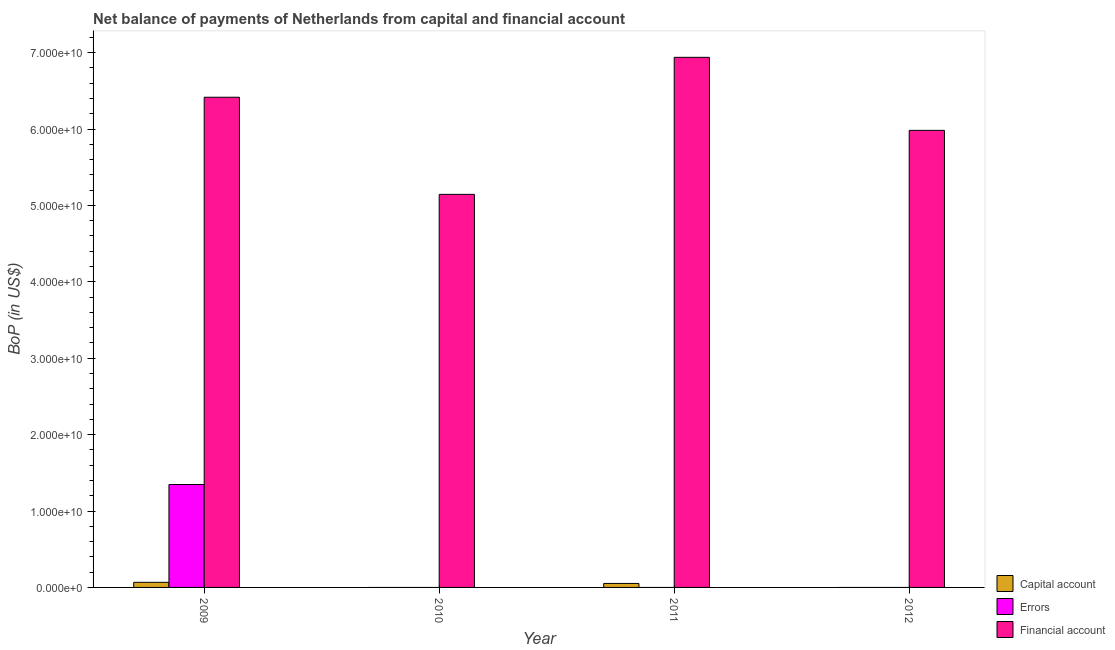How many different coloured bars are there?
Make the answer very short. 3. Are the number of bars on each tick of the X-axis equal?
Ensure brevity in your answer.  No. What is the label of the 4th group of bars from the left?
Keep it short and to the point. 2012. In how many cases, is the number of bars for a given year not equal to the number of legend labels?
Your response must be concise. 3. What is the amount of net capital account in 2011?
Keep it short and to the point. 5.21e+08. Across all years, what is the maximum amount of financial account?
Keep it short and to the point. 6.94e+1. What is the total amount of financial account in the graph?
Give a very brief answer. 2.45e+11. What is the difference between the amount of financial account in 2009 and that in 2012?
Offer a terse response. 4.34e+09. What is the difference between the amount of errors in 2011 and the amount of financial account in 2009?
Give a very brief answer. -1.35e+1. What is the average amount of net capital account per year?
Offer a very short reply. 2.97e+08. In the year 2011, what is the difference between the amount of net capital account and amount of errors?
Keep it short and to the point. 0. In how many years, is the amount of errors greater than 66000000000 US$?
Keep it short and to the point. 0. What is the ratio of the amount of financial account in 2009 to that in 2011?
Ensure brevity in your answer.  0.92. What is the difference between the highest and the second highest amount of financial account?
Keep it short and to the point. 5.22e+09. What is the difference between the highest and the lowest amount of errors?
Keep it short and to the point. 1.35e+1. In how many years, is the amount of net capital account greater than the average amount of net capital account taken over all years?
Your answer should be very brief. 2. Is the sum of the amount of financial account in 2009 and 2011 greater than the maximum amount of net capital account across all years?
Ensure brevity in your answer.  Yes. Is it the case that in every year, the sum of the amount of net capital account and amount of errors is greater than the amount of financial account?
Your answer should be very brief. No. How many years are there in the graph?
Give a very brief answer. 4. What is the difference between two consecutive major ticks on the Y-axis?
Provide a succinct answer. 1.00e+1. Does the graph contain grids?
Your answer should be compact. No. Where does the legend appear in the graph?
Your response must be concise. Bottom right. How are the legend labels stacked?
Your answer should be very brief. Vertical. What is the title of the graph?
Keep it short and to the point. Net balance of payments of Netherlands from capital and financial account. What is the label or title of the Y-axis?
Your answer should be compact. BoP (in US$). What is the BoP (in US$) in Capital account in 2009?
Ensure brevity in your answer.  6.68e+08. What is the BoP (in US$) in Errors in 2009?
Provide a short and direct response. 1.35e+1. What is the BoP (in US$) in Financial account in 2009?
Make the answer very short. 6.42e+1. What is the BoP (in US$) in Capital account in 2010?
Your response must be concise. 0. What is the BoP (in US$) of Errors in 2010?
Offer a terse response. 0. What is the BoP (in US$) of Financial account in 2010?
Ensure brevity in your answer.  5.14e+1. What is the BoP (in US$) in Capital account in 2011?
Offer a very short reply. 5.21e+08. What is the BoP (in US$) of Errors in 2011?
Your answer should be compact. 0. What is the BoP (in US$) of Financial account in 2011?
Your response must be concise. 6.94e+1. What is the BoP (in US$) in Capital account in 2012?
Offer a very short reply. 0. What is the BoP (in US$) of Errors in 2012?
Make the answer very short. 0. What is the BoP (in US$) of Financial account in 2012?
Offer a very short reply. 5.98e+1. Across all years, what is the maximum BoP (in US$) in Capital account?
Provide a succinct answer. 6.68e+08. Across all years, what is the maximum BoP (in US$) of Errors?
Keep it short and to the point. 1.35e+1. Across all years, what is the maximum BoP (in US$) in Financial account?
Your answer should be compact. 6.94e+1. Across all years, what is the minimum BoP (in US$) in Capital account?
Provide a succinct answer. 0. Across all years, what is the minimum BoP (in US$) in Financial account?
Ensure brevity in your answer.  5.14e+1. What is the total BoP (in US$) of Capital account in the graph?
Your answer should be compact. 1.19e+09. What is the total BoP (in US$) of Errors in the graph?
Ensure brevity in your answer.  1.35e+1. What is the total BoP (in US$) of Financial account in the graph?
Keep it short and to the point. 2.45e+11. What is the difference between the BoP (in US$) in Financial account in 2009 and that in 2010?
Your answer should be very brief. 1.27e+1. What is the difference between the BoP (in US$) of Capital account in 2009 and that in 2011?
Ensure brevity in your answer.  1.47e+08. What is the difference between the BoP (in US$) of Financial account in 2009 and that in 2011?
Your answer should be very brief. -5.22e+09. What is the difference between the BoP (in US$) of Financial account in 2009 and that in 2012?
Provide a short and direct response. 4.34e+09. What is the difference between the BoP (in US$) of Financial account in 2010 and that in 2011?
Offer a terse response. -1.79e+1. What is the difference between the BoP (in US$) of Financial account in 2010 and that in 2012?
Offer a terse response. -8.37e+09. What is the difference between the BoP (in US$) of Financial account in 2011 and that in 2012?
Ensure brevity in your answer.  9.56e+09. What is the difference between the BoP (in US$) in Capital account in 2009 and the BoP (in US$) in Financial account in 2010?
Provide a succinct answer. -5.08e+1. What is the difference between the BoP (in US$) of Errors in 2009 and the BoP (in US$) of Financial account in 2010?
Make the answer very short. -3.80e+1. What is the difference between the BoP (in US$) in Capital account in 2009 and the BoP (in US$) in Financial account in 2011?
Give a very brief answer. -6.87e+1. What is the difference between the BoP (in US$) of Errors in 2009 and the BoP (in US$) of Financial account in 2011?
Your response must be concise. -5.59e+1. What is the difference between the BoP (in US$) in Capital account in 2009 and the BoP (in US$) in Financial account in 2012?
Provide a succinct answer. -5.92e+1. What is the difference between the BoP (in US$) of Errors in 2009 and the BoP (in US$) of Financial account in 2012?
Provide a short and direct response. -4.63e+1. What is the difference between the BoP (in US$) of Capital account in 2011 and the BoP (in US$) of Financial account in 2012?
Provide a succinct answer. -5.93e+1. What is the average BoP (in US$) in Capital account per year?
Provide a succinct answer. 2.97e+08. What is the average BoP (in US$) in Errors per year?
Provide a short and direct response. 3.37e+09. What is the average BoP (in US$) in Financial account per year?
Make the answer very short. 6.12e+1. In the year 2009, what is the difference between the BoP (in US$) in Capital account and BoP (in US$) in Errors?
Keep it short and to the point. -1.28e+1. In the year 2009, what is the difference between the BoP (in US$) of Capital account and BoP (in US$) of Financial account?
Your answer should be compact. -6.35e+1. In the year 2009, what is the difference between the BoP (in US$) in Errors and BoP (in US$) in Financial account?
Your answer should be compact. -5.07e+1. In the year 2011, what is the difference between the BoP (in US$) in Capital account and BoP (in US$) in Financial account?
Your answer should be compact. -6.89e+1. What is the ratio of the BoP (in US$) in Financial account in 2009 to that in 2010?
Offer a terse response. 1.25. What is the ratio of the BoP (in US$) in Capital account in 2009 to that in 2011?
Provide a short and direct response. 1.28. What is the ratio of the BoP (in US$) of Financial account in 2009 to that in 2011?
Ensure brevity in your answer.  0.92. What is the ratio of the BoP (in US$) of Financial account in 2009 to that in 2012?
Provide a short and direct response. 1.07. What is the ratio of the BoP (in US$) in Financial account in 2010 to that in 2011?
Your response must be concise. 0.74. What is the ratio of the BoP (in US$) of Financial account in 2010 to that in 2012?
Offer a terse response. 0.86. What is the ratio of the BoP (in US$) of Financial account in 2011 to that in 2012?
Ensure brevity in your answer.  1.16. What is the difference between the highest and the second highest BoP (in US$) in Financial account?
Ensure brevity in your answer.  5.22e+09. What is the difference between the highest and the lowest BoP (in US$) in Capital account?
Ensure brevity in your answer.  6.68e+08. What is the difference between the highest and the lowest BoP (in US$) of Errors?
Make the answer very short. 1.35e+1. What is the difference between the highest and the lowest BoP (in US$) in Financial account?
Ensure brevity in your answer.  1.79e+1. 